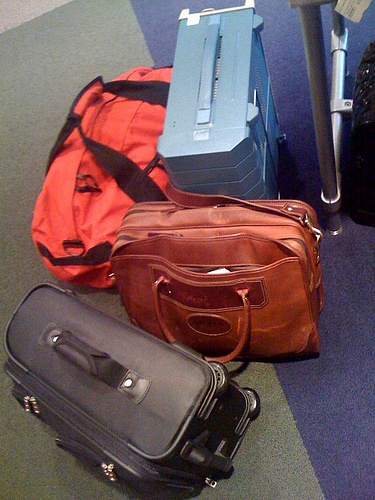Describe the objects in this image and their specific colors. I can see suitcase in darkgray, gray, and black tones, handbag in darkgray, maroon, brown, black, and salmon tones, and suitcase in darkgray, lightblue, navy, and darkblue tones in this image. 